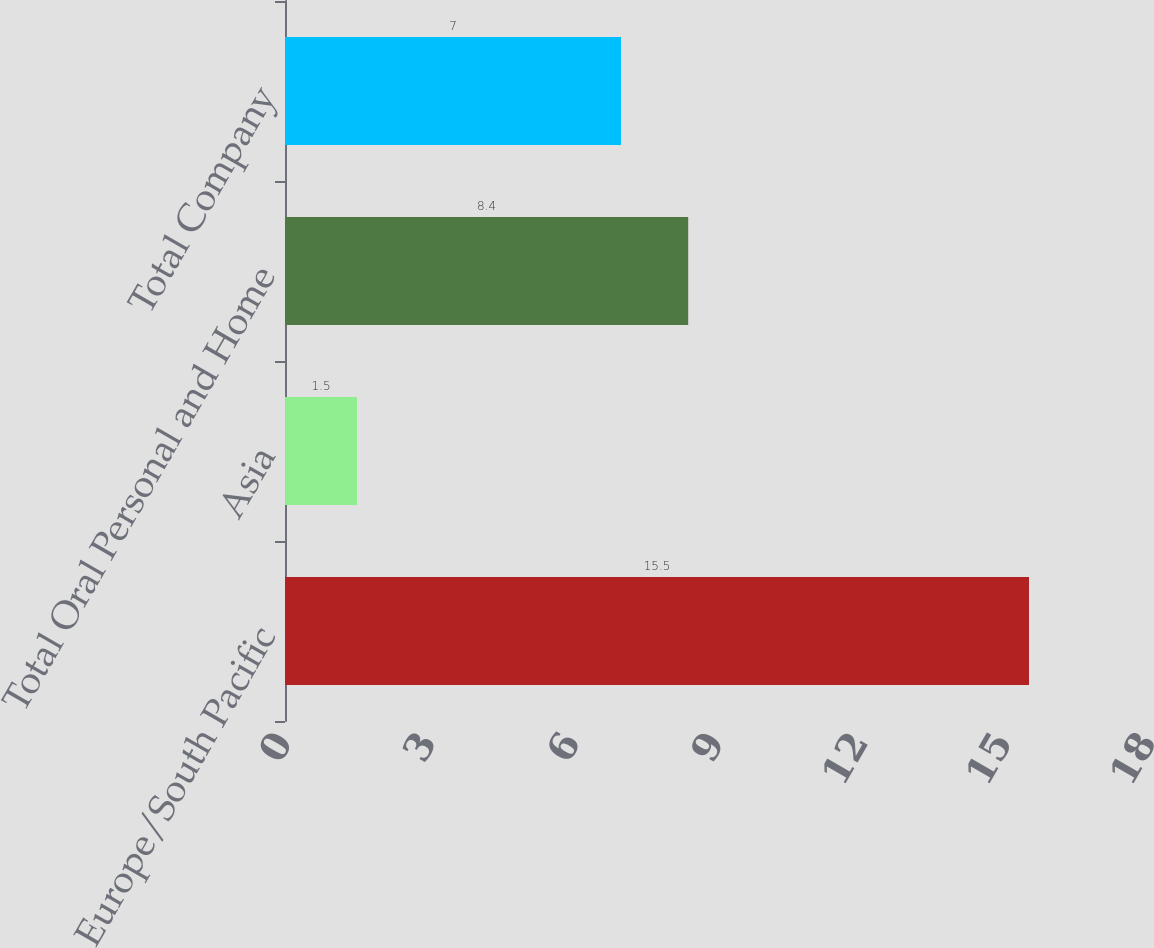<chart> <loc_0><loc_0><loc_500><loc_500><bar_chart><fcel>Europe/South Pacific<fcel>Asia<fcel>Total Oral Personal and Home<fcel>Total Company<nl><fcel>15.5<fcel>1.5<fcel>8.4<fcel>7<nl></chart> 